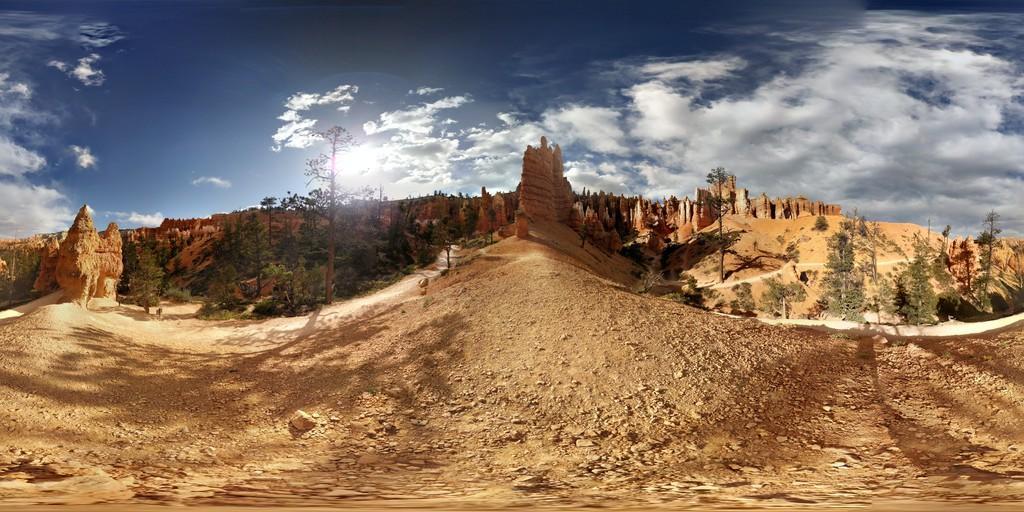Please provide a concise description of this image. In this image we can see a clear and sunny with the slightly cloudy sky. There are many trees and hills in the image. 